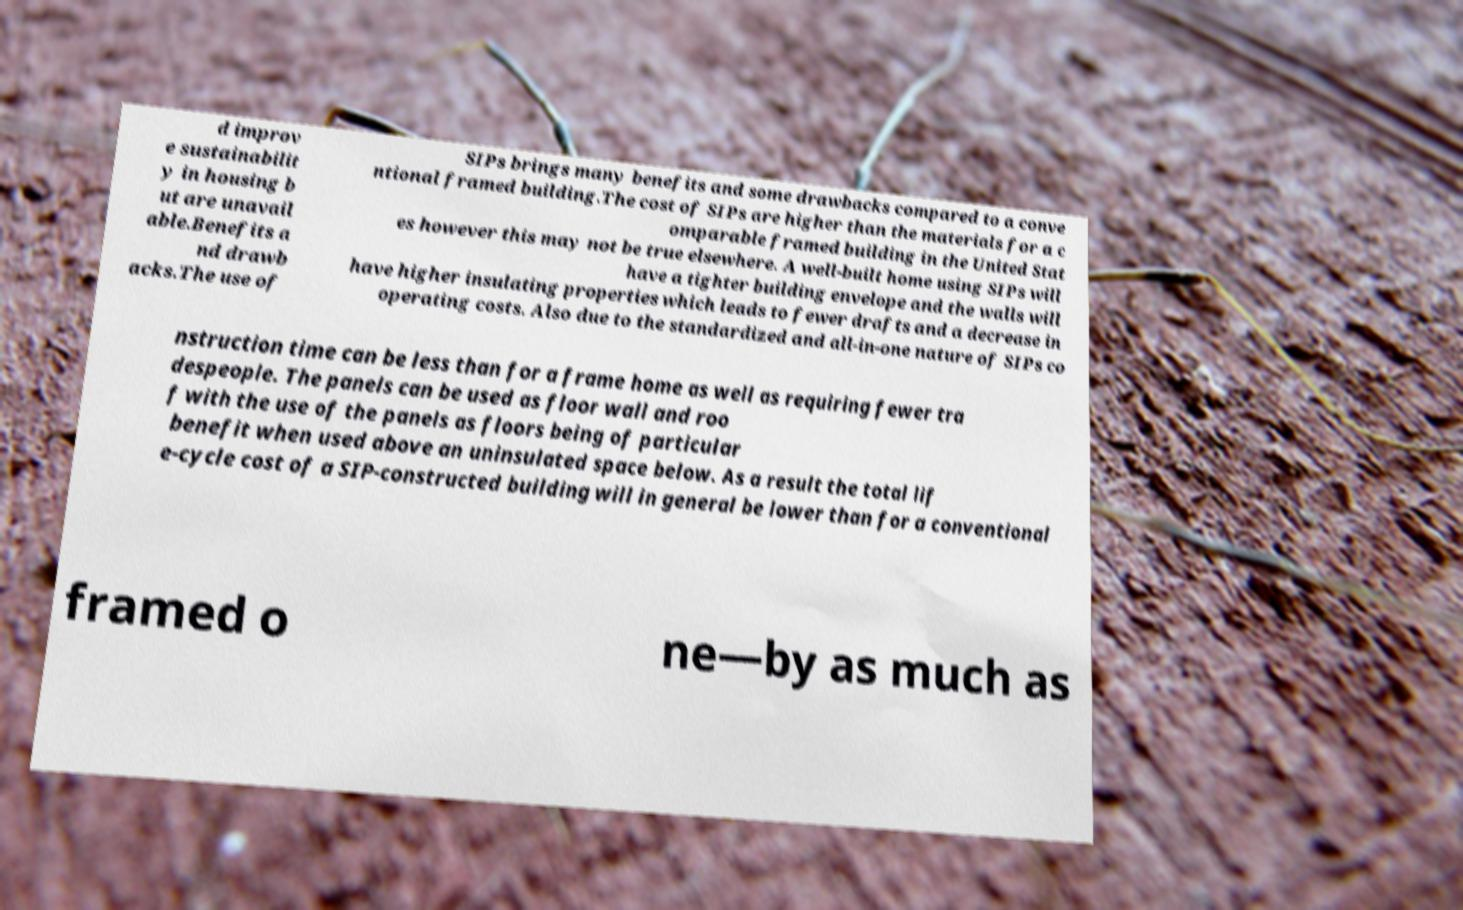Could you assist in decoding the text presented in this image and type it out clearly? d improv e sustainabilit y in housing b ut are unavail able.Benefits a nd drawb acks.The use of SIPs brings many benefits and some drawbacks compared to a conve ntional framed building.The cost of SIPs are higher than the materials for a c omparable framed building in the United Stat es however this may not be true elsewhere. A well-built home using SIPs will have a tighter building envelope and the walls will have higher insulating properties which leads to fewer drafts and a decrease in operating costs. Also due to the standardized and all-in-one nature of SIPs co nstruction time can be less than for a frame home as well as requiring fewer tra despeople. The panels can be used as floor wall and roo f with the use of the panels as floors being of particular benefit when used above an uninsulated space below. As a result the total lif e-cycle cost of a SIP-constructed building will in general be lower than for a conventional framed o ne—by as much as 